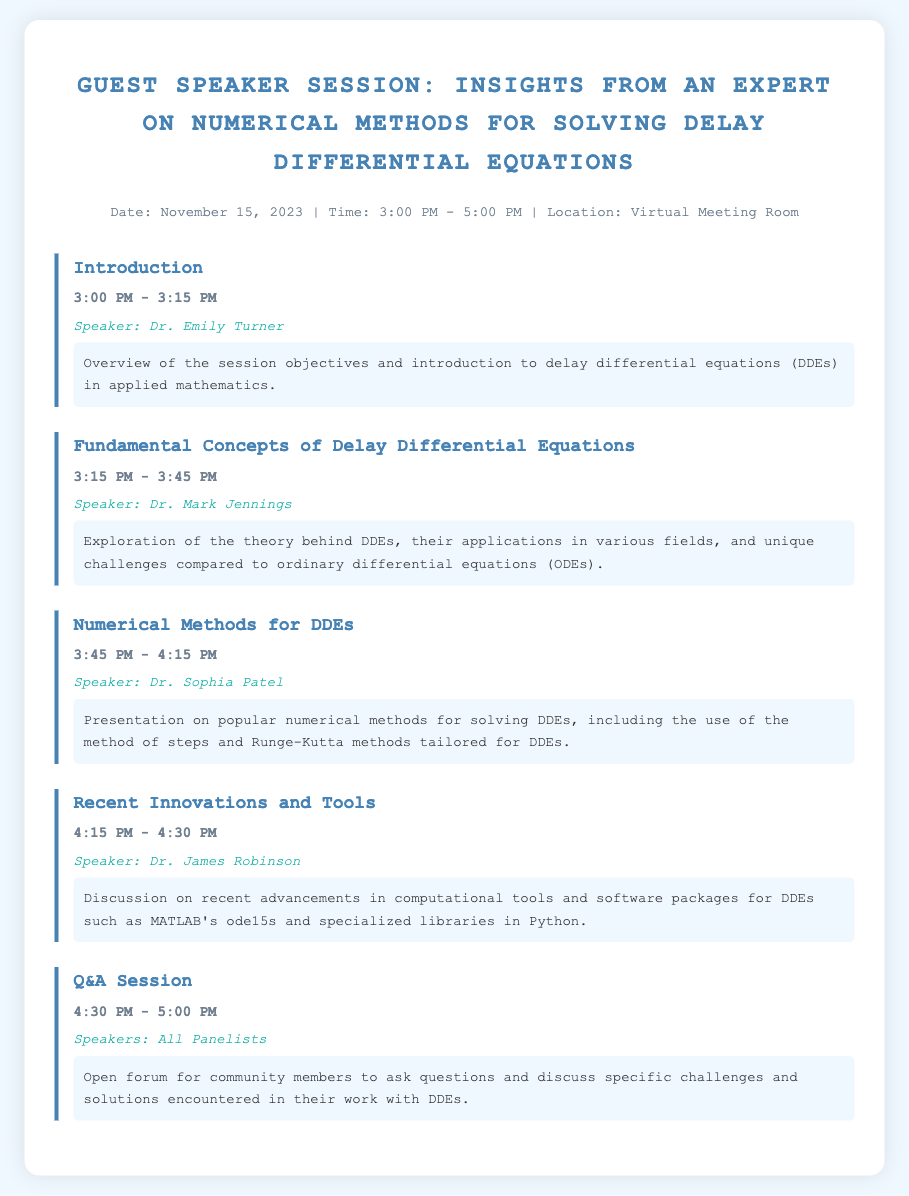What is the date of the session? The document specifies the date as November 15, 2023.
Answer: November 15, 2023 Who is the speaker for the introduction? The introduction section mentions Dr. Emily Turner as the speaker.
Answer: Dr. Emily Turner What time does the Q&A session begin? The Q&A session is scheduled to start at 4:30 PM according to the agenda.
Answer: 4:30 PM Which topic is Dr. Sophia Patel presenting on? Dr. Sophia Patel's section focuses on numerical methods for solving DDEs.
Answer: Numerical Methods for DDEs What unique challenges do DDEs present compared to ODEs? The agenda notes that the fundamental concepts section will discuss these unique challenges.
Answer: Unique challenges compared to ordinary differential equations How long is the session on recent innovations and tools? The section on recent innovations and tools lasts for 15 minutes, from 4:15 PM to 4:30 PM.
Answer: 15 minutes What is the last item on the agenda? The last item on the agenda is the Q&A session for community discussions.
Answer: Q&A Session What time does the session end? The agenda indicates that the session concludes at 5:00 PM.
Answer: 5:00 PM 